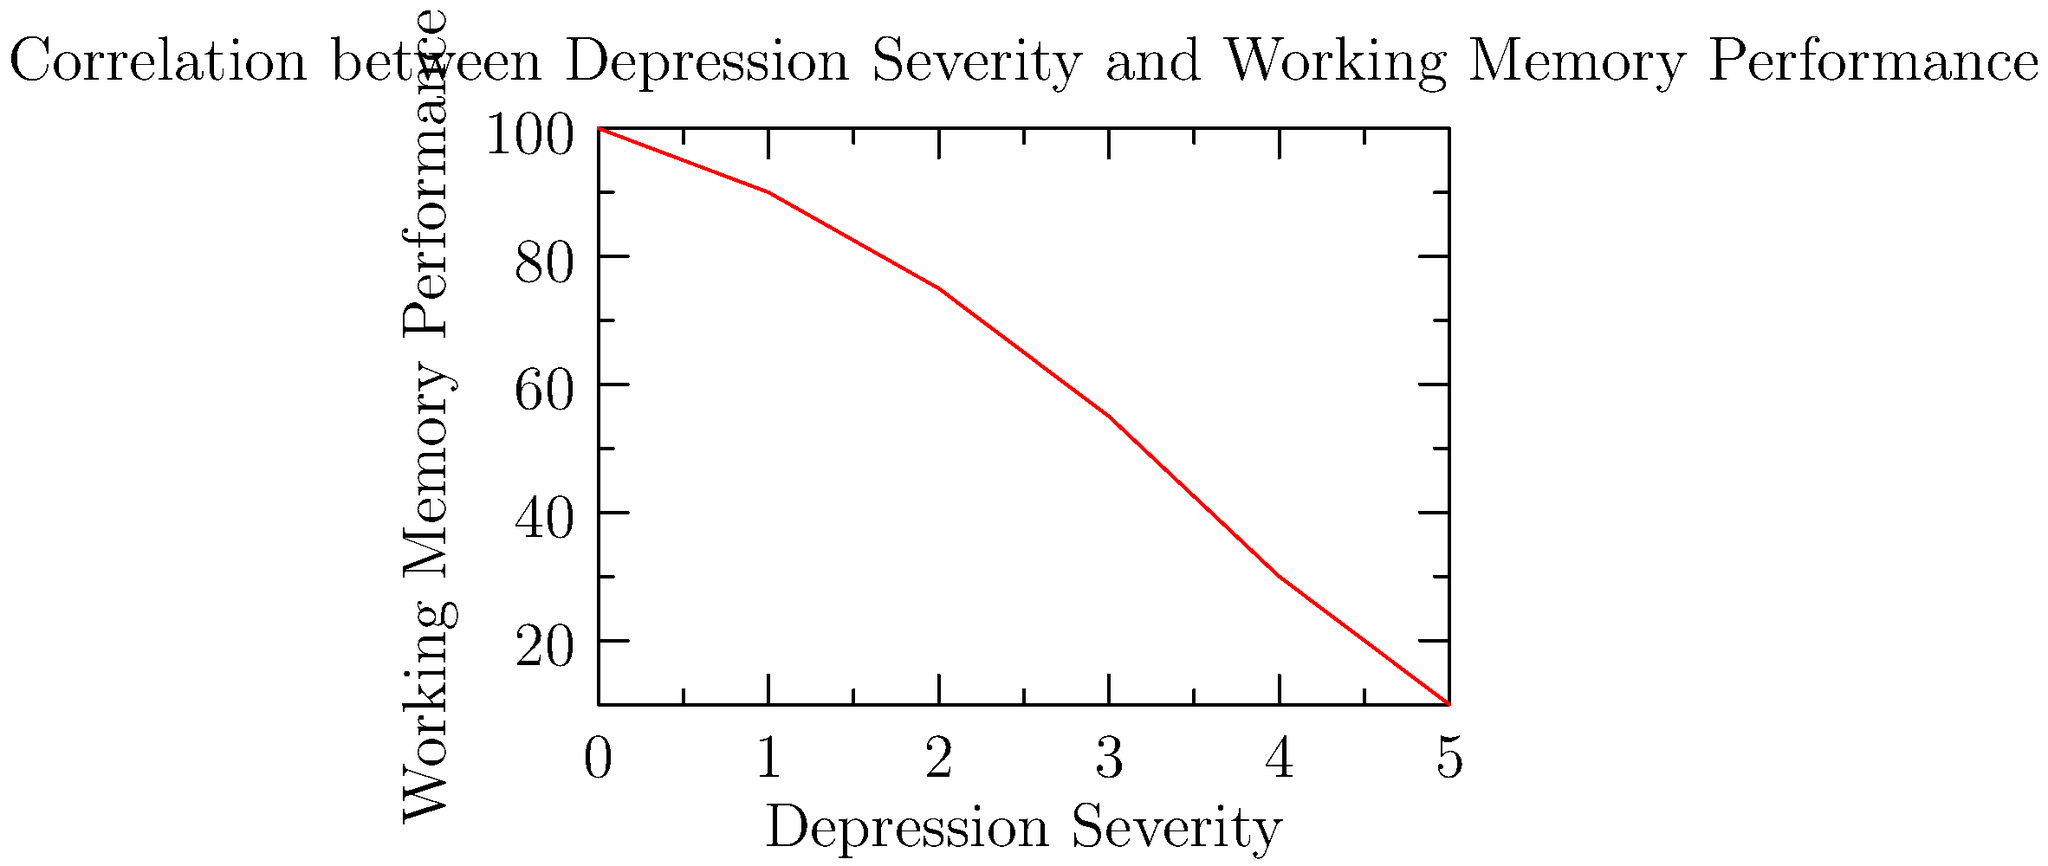Based on the line graph, what can be inferred about the relationship between depression severity and working memory performance in patients with depression? To interpret this graph and understand the relationship between depression severity and working memory performance, we need to follow these steps:

1. Identify the variables:
   - X-axis: Depression Severity (increasing from left to right)
   - Y-axis: Working Memory Performance (increasing from bottom to top)

2. Observe the trend of the line:
   - The line starts high on the left side and decreases as it moves to the right

3. Interpret the trend:
   - As depression severity increases (moving right on the x-axis), working memory performance decreases (moving down on the y-axis)

4. Analyze the shape of the line:
   - The line appears to be roughly linear, indicating a consistent relationship between the two variables

5. Consider the strength of the relationship:
   - The line shows a clear downward trend, suggesting a strong negative correlation

6. Relate to psychiatric knowledge:
   - This relationship aligns with clinical observations that increased depression severity is often associated with decreased cognitive function, particularly in areas like working memory

Based on these observations, we can conclude that there is a negative correlation between depression severity and working memory performance. As depression becomes more severe, working memory performance tends to decline.
Answer: Negative correlation: As depression severity increases, working memory performance decreases. 